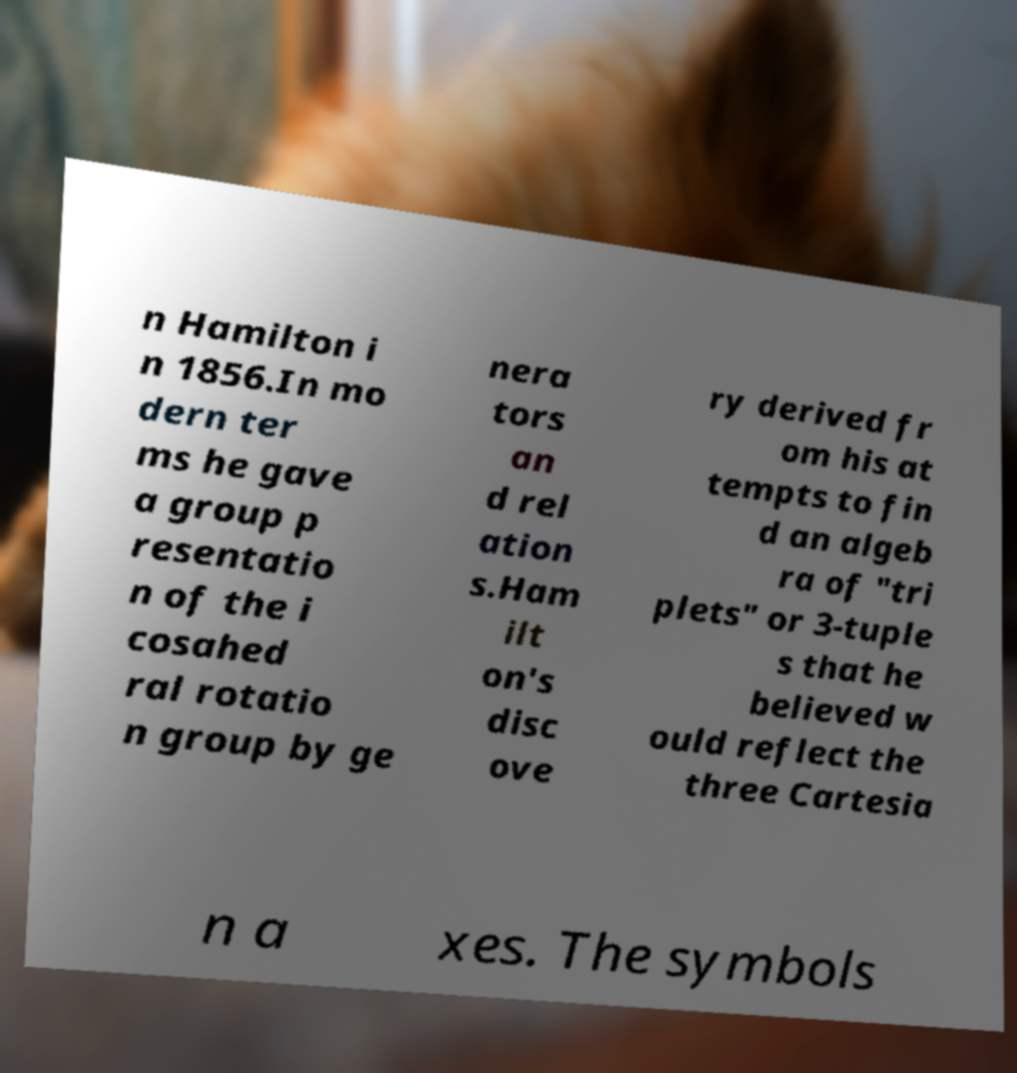There's text embedded in this image that I need extracted. Can you transcribe it verbatim? n Hamilton i n 1856.In mo dern ter ms he gave a group p resentatio n of the i cosahed ral rotatio n group by ge nera tors an d rel ation s.Ham ilt on's disc ove ry derived fr om his at tempts to fin d an algeb ra of "tri plets" or 3-tuple s that he believed w ould reflect the three Cartesia n a xes. The symbols 